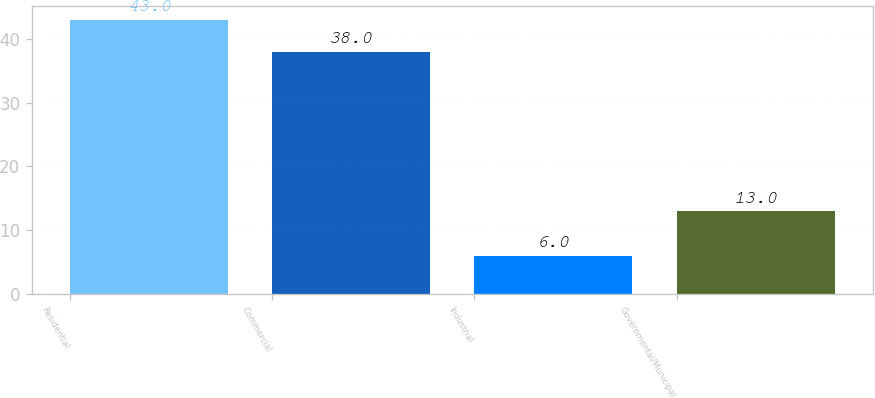<chart> <loc_0><loc_0><loc_500><loc_500><bar_chart><fcel>Residential<fcel>Commercial<fcel>Industrial<fcel>Governmental/Municipal<nl><fcel>43<fcel>38<fcel>6<fcel>13<nl></chart> 